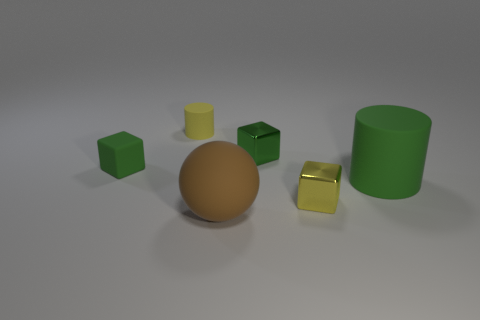Add 1 metallic objects. How many objects exist? 7 Subtract all cylinders. How many objects are left? 4 Subtract all green cubes. Subtract all tiny yellow metal objects. How many objects are left? 3 Add 2 large rubber balls. How many large rubber balls are left? 3 Add 3 big brown objects. How many big brown objects exist? 4 Subtract 0 cyan cylinders. How many objects are left? 6 